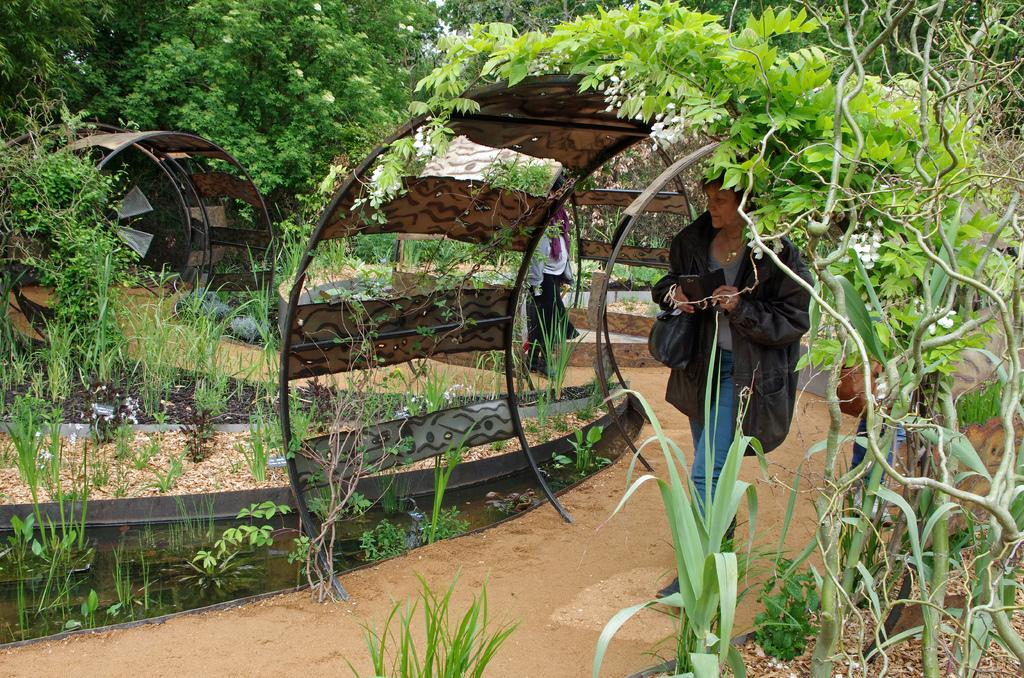How many people are present in the image? There are two people in the image. What can be seen in the image besides the people? There are dome-shaped objects in the image. What type of natural elements can be seen in the background of the image? There are trees and plants in the background of the image. What type of chalk is being used by the people in the image? There is no chalk present in the image; it features two people and dome-shaped objects. What is the result of the addition problem written on the dome-shaped objects? There is no addition problem written on the dome-shaped objects in the image. 